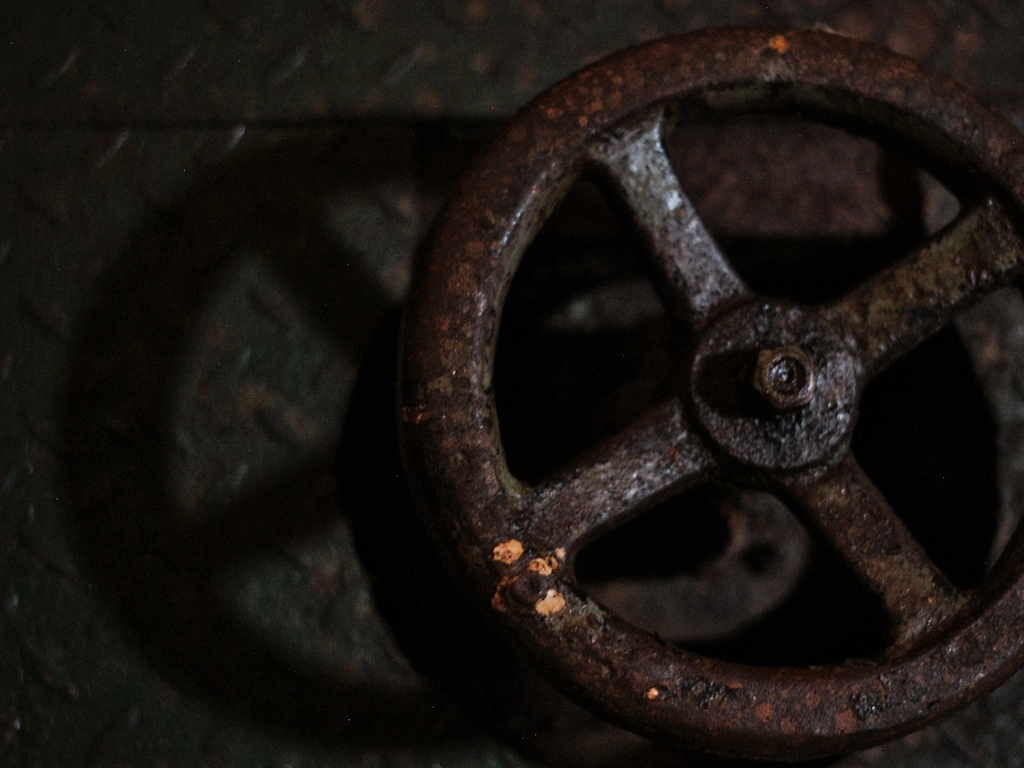How might this object be repurposed in a modern setting? This valve wheel could be repurposed as a decorative piece, perhaps mounted on a wall or integrated into furniture to add an industrial vintage charm. It also could be used as part of a functional art installation, where it interacts with other elements to create kinetic sculptures. 